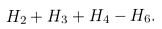Convert formula to latex. <formula><loc_0><loc_0><loc_500><loc_500>H _ { 2 } + H _ { 3 } + H _ { 4 } - H _ { 6 } .</formula> 